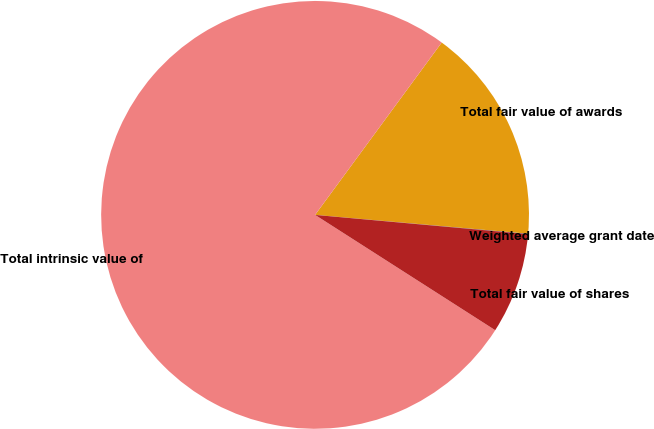<chart> <loc_0><loc_0><loc_500><loc_500><pie_chart><fcel>Weighted average grant date<fcel>Total fair value of awards<fcel>Total intrinsic value of<fcel>Total fair value of shares<nl><fcel>0.03%<fcel>16.32%<fcel>76.03%<fcel>7.63%<nl></chart> 